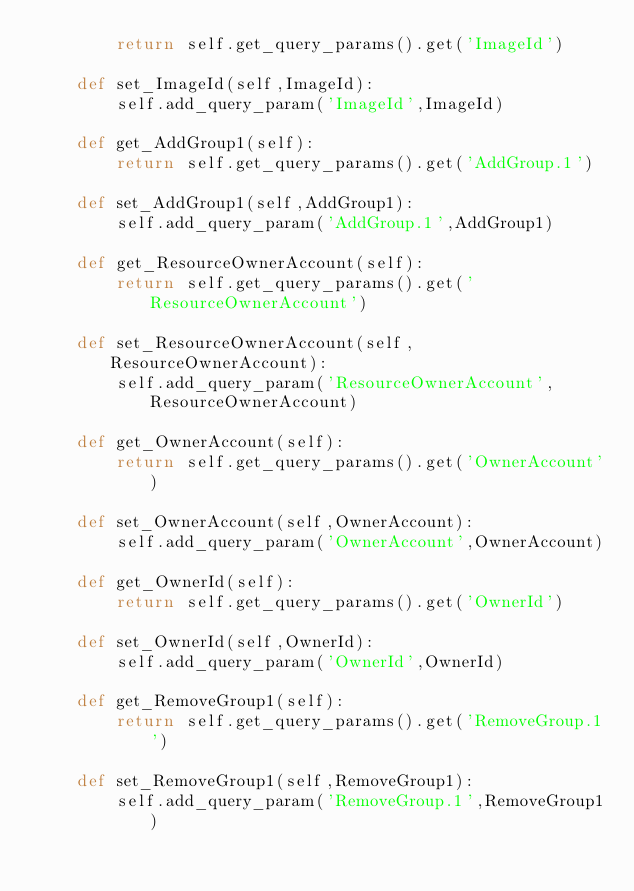Convert code to text. <code><loc_0><loc_0><loc_500><loc_500><_Python_>		return self.get_query_params().get('ImageId')

	def set_ImageId(self,ImageId):
		self.add_query_param('ImageId',ImageId)

	def get_AddGroup1(self):
		return self.get_query_params().get('AddGroup.1')

	def set_AddGroup1(self,AddGroup1):
		self.add_query_param('AddGroup.1',AddGroup1)

	def get_ResourceOwnerAccount(self):
		return self.get_query_params().get('ResourceOwnerAccount')

	def set_ResourceOwnerAccount(self,ResourceOwnerAccount):
		self.add_query_param('ResourceOwnerAccount',ResourceOwnerAccount)

	def get_OwnerAccount(self):
		return self.get_query_params().get('OwnerAccount')

	def set_OwnerAccount(self,OwnerAccount):
		self.add_query_param('OwnerAccount',OwnerAccount)

	def get_OwnerId(self):
		return self.get_query_params().get('OwnerId')

	def set_OwnerId(self,OwnerId):
		self.add_query_param('OwnerId',OwnerId)

	def get_RemoveGroup1(self):
		return self.get_query_params().get('RemoveGroup.1')

	def set_RemoveGroup1(self,RemoveGroup1):
		self.add_query_param('RemoveGroup.1',RemoveGroup1)</code> 